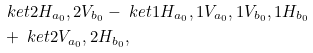<formula> <loc_0><loc_0><loc_500><loc_500>& \ k e t { 2 H _ { a _ { 0 } } , 2 V _ { b _ { 0 } } } - \ k e t { 1 H _ { a _ { 0 } } , 1 V _ { a _ { 0 } } , 1 V _ { b _ { 0 } } , 1 H _ { b _ { 0 } } } \\ & + \ k e t { 2 V _ { a _ { 0 } } , 2 H _ { b _ { 0 } } } ,</formula> 